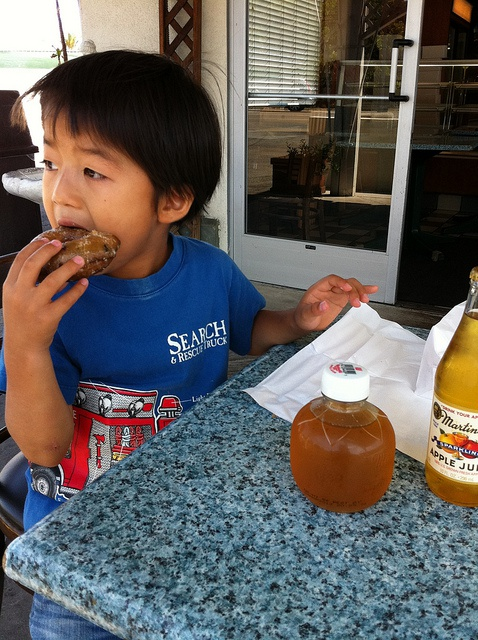Describe the objects in this image and their specific colors. I can see dining table in white, gray, blue, and lightgray tones, people in white, black, navy, salmon, and brown tones, bottle in white, maroon, and brown tones, bottle in white, orange, olive, beige, and tan tones, and donut in white, maroon, brown, and black tones in this image. 